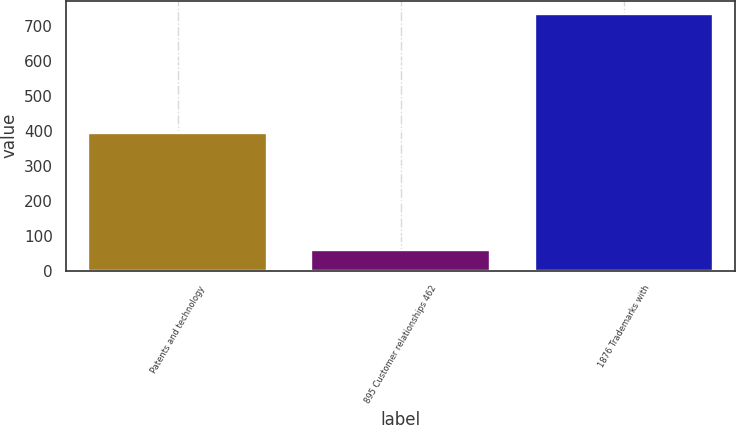<chart> <loc_0><loc_0><loc_500><loc_500><bar_chart><fcel>Patents and technology<fcel>895 Customer relationships 462<fcel>1876 Trademarks with<nl><fcel>395<fcel>60<fcel>736<nl></chart> 